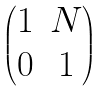<formula> <loc_0><loc_0><loc_500><loc_500>\begin{pmatrix} 1 & N \\ 0 & 1 \end{pmatrix}</formula> 